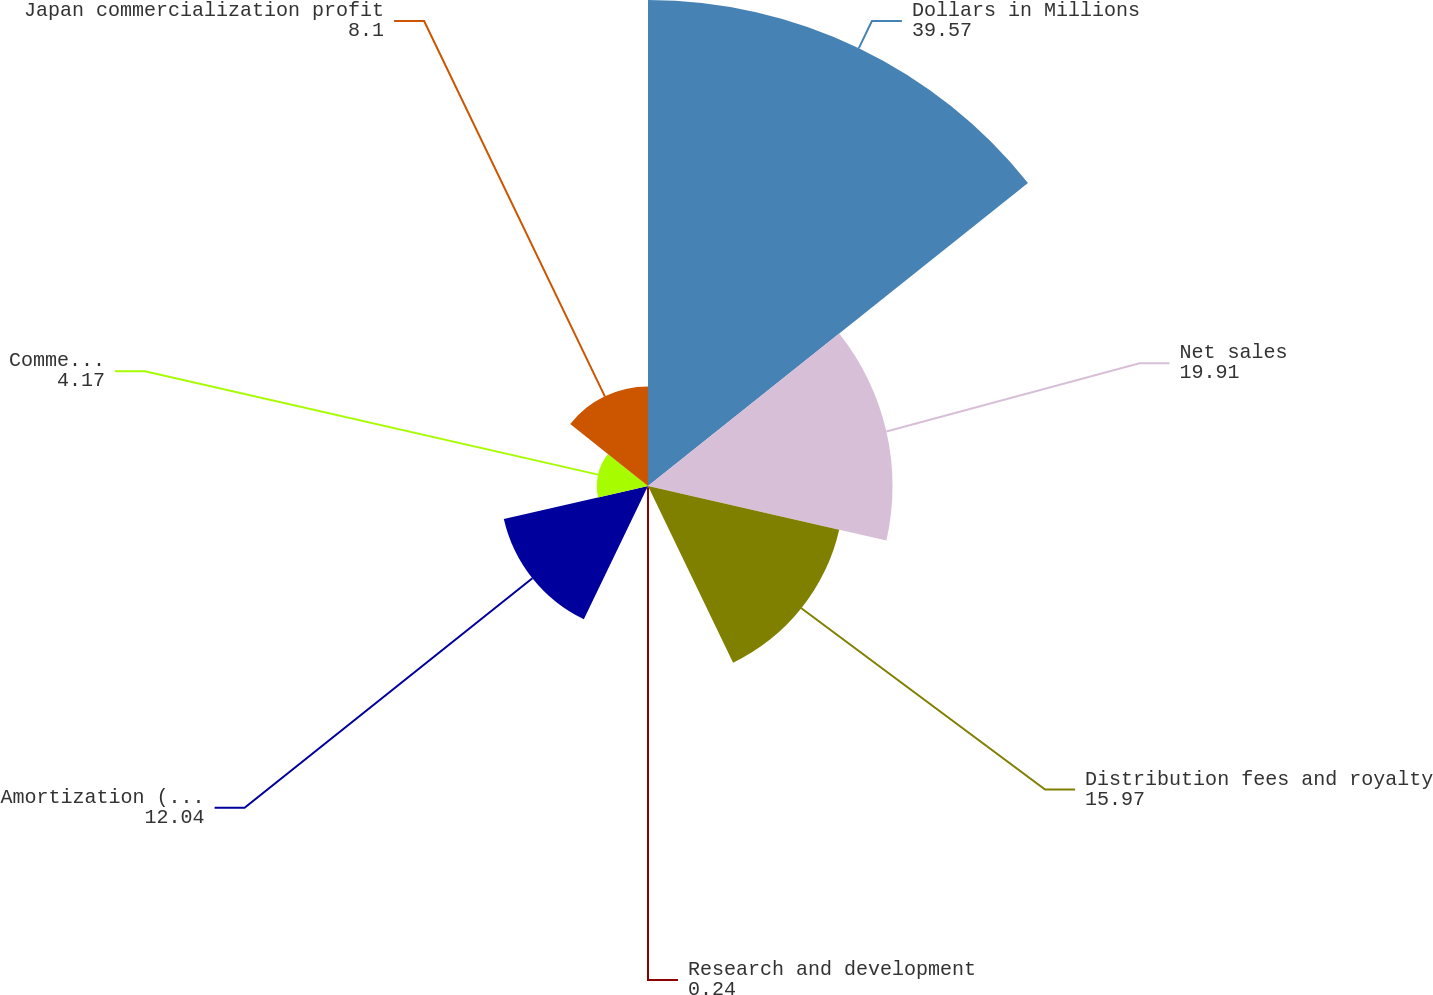<chart> <loc_0><loc_0><loc_500><loc_500><pie_chart><fcel>Dollars in Millions<fcel>Net sales<fcel>Distribution fees and royalty<fcel>Research and development<fcel>Amortization (income)/expense<fcel>Commercialization expense<fcel>Japan commercialization profit<nl><fcel>39.57%<fcel>19.91%<fcel>15.97%<fcel>0.24%<fcel>12.04%<fcel>4.17%<fcel>8.1%<nl></chart> 